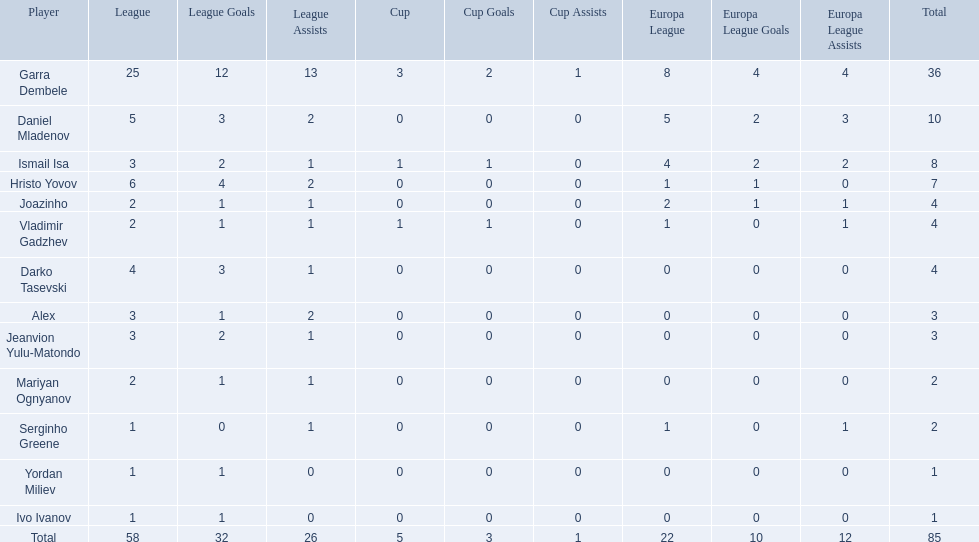Who are all of the players? Garra Dembele, Daniel Mladenov, Ismail Isa, Hristo Yovov, Joazinho, Vladimir Gadzhev, Darko Tasevski, Alex, Jeanvion Yulu-Matondo, Mariyan Ognyanov, Serginho Greene, Yordan Miliev, Ivo Ivanov. And which league is each player in? 25, 5, 3, 6, 2, 2, 4, 3, 3, 2, 1, 1, 1. Along with vladimir gadzhev and joazinho, which other player is in league 2? Mariyan Ognyanov. 